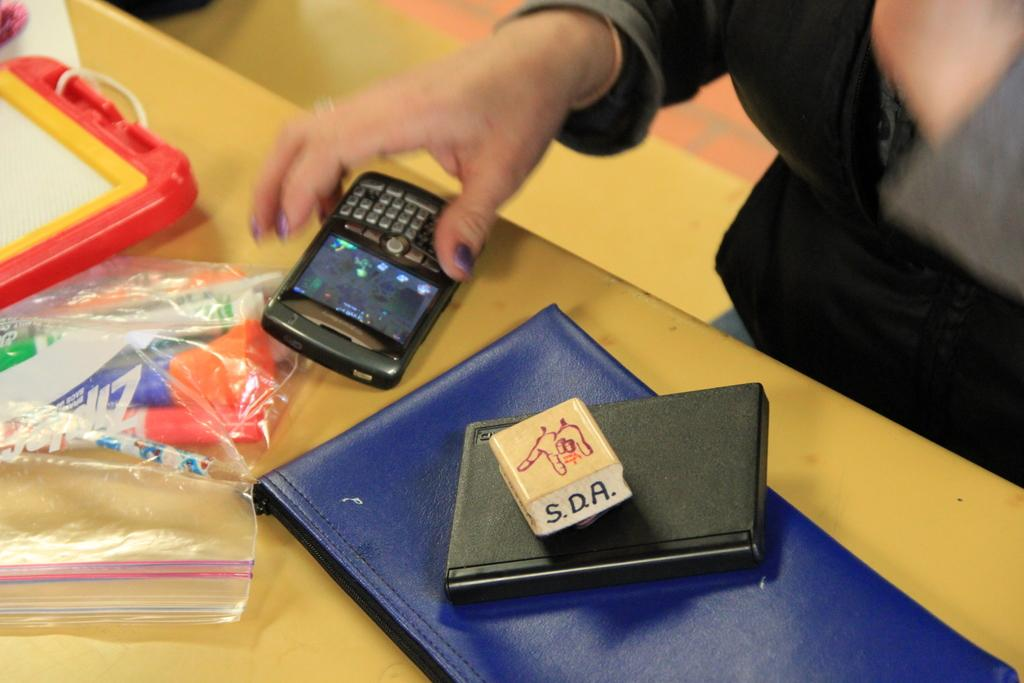<image>
Create a compact narrative representing the image presented. A Blackberry phone along with a stamp that has S.D.A. written on it. 